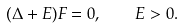Convert formula to latex. <formula><loc_0><loc_0><loc_500><loc_500>( \Delta + E ) F = 0 , \quad E > 0 .</formula> 